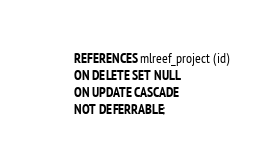<code> <loc_0><loc_0><loc_500><loc_500><_SQL_>        REFERENCES mlreef_project (id)
        ON DELETE SET NULL
        ON UPDATE CASCADE
        NOT DEFERRABLE;

</code> 